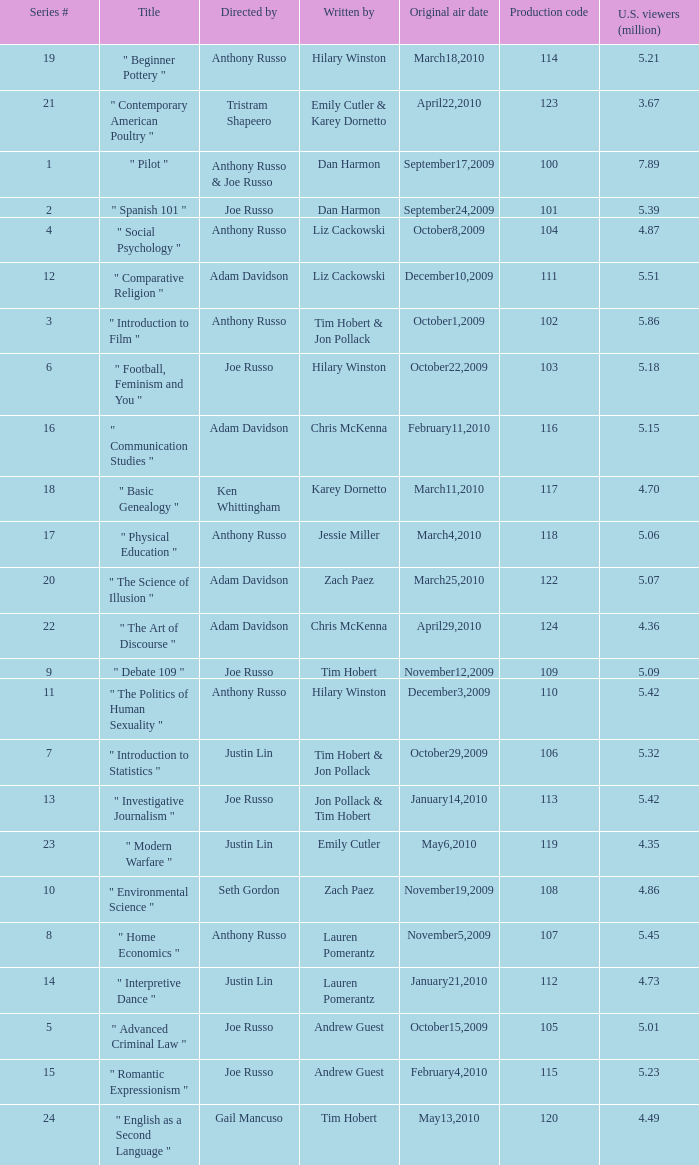How many episodes had a production code 120? 1.0. 